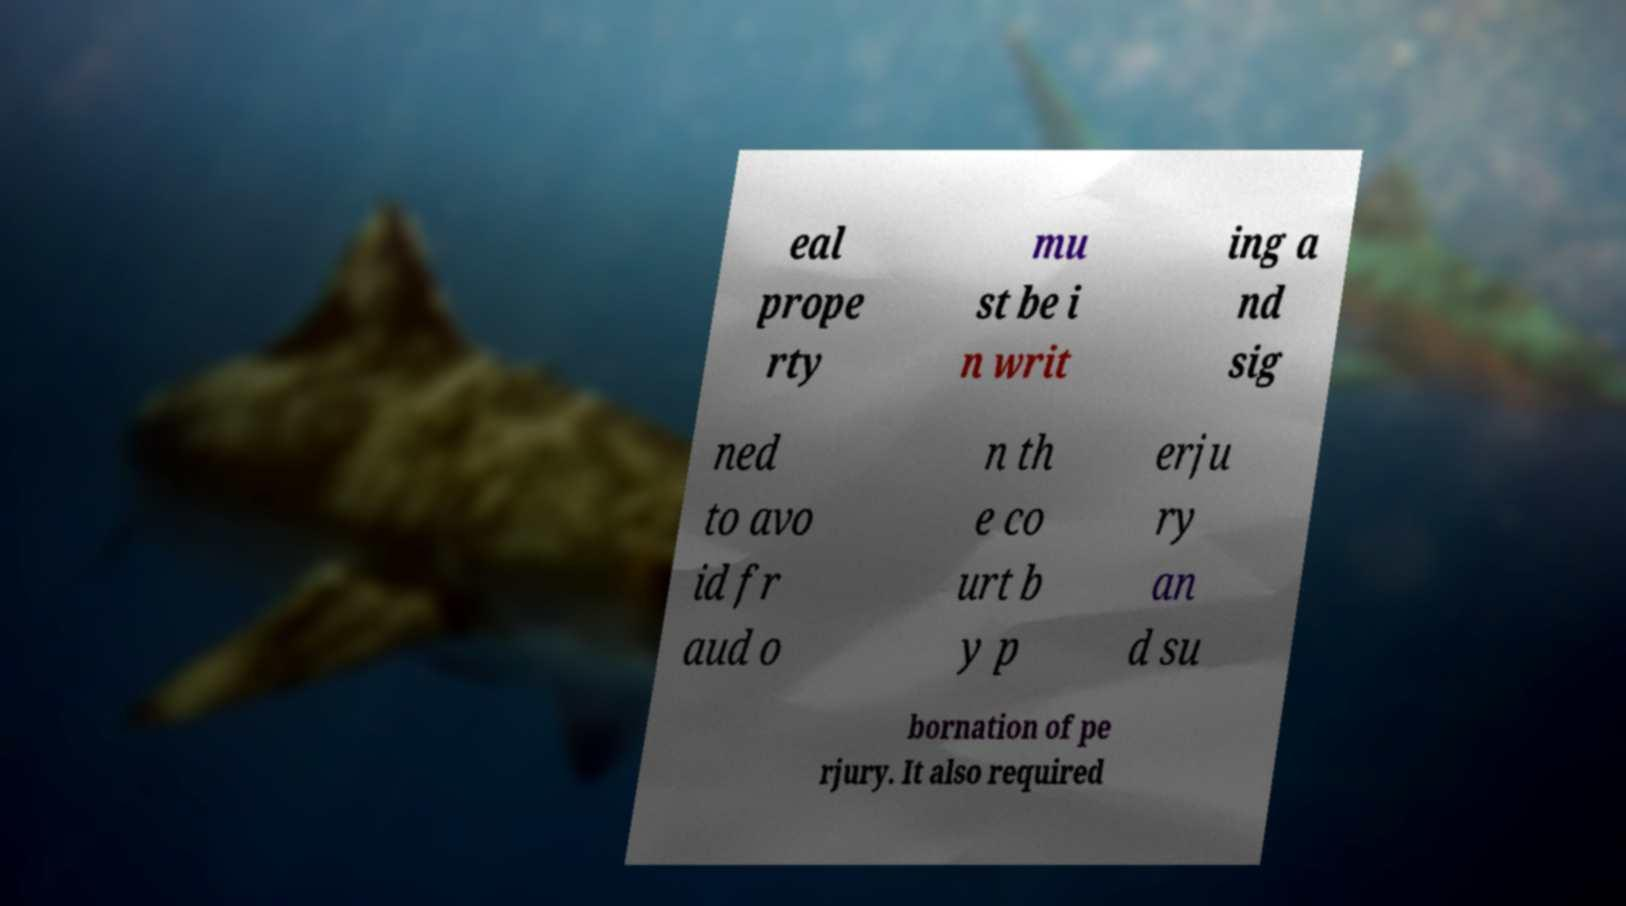Please identify and transcribe the text found in this image. eal prope rty mu st be i n writ ing a nd sig ned to avo id fr aud o n th e co urt b y p erju ry an d su bornation of pe rjury. It also required 